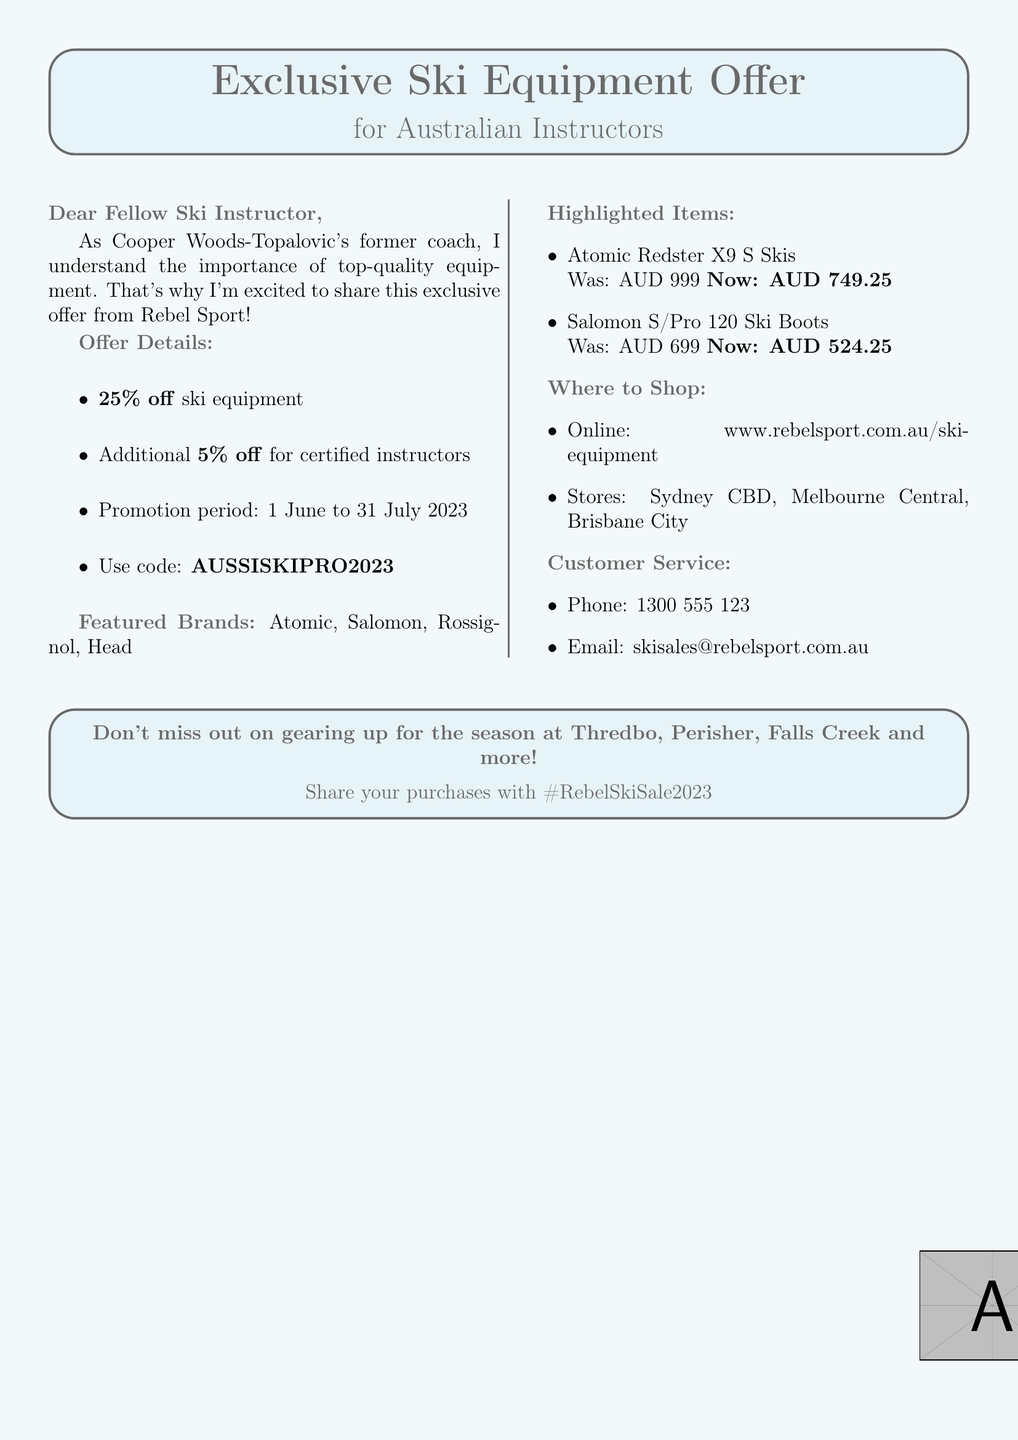what is the discount percentage offered on ski equipment? The document states that there is a discount of 25% on ski equipment.
Answer: 25% what is the exclusive offer for certified ski instructors? The document mentions an additional 5% off for certified ski instructors.
Answer: 5% what is the promotion period for the offer? The document specifies that the promotion period is from 1 June to 31 July 2023.
Answer: 1 June to 31 July 2023 which ski brand is featured in the promotion? The document lists Atomic, Salomon, Rossignol, and Head as featured brands.
Answer: Atomic, Salomon, Rossignol, Head what is the discounted price of the Atomic Redster X9 S Skis? The document states the discounted price of the Atomic Redster X9 S Skis is AUD 749.25.
Answer: AUD 749.25 what is the redemption code for the special offer? The redemption code provided in the document is AUSSISKIPRO2023.
Answer: AUSSISKIPRO2023 how many store locations are mentioned in the document? The document lists three store locations: Sydney CBD, Melbourne Central, and Brisbane City.
Answer: 3 where can customers shop online? The document indicates that customers can shop online at www.rebelsport.com.au/ski-equipment.
Answer: www.rebelsport.com.au/ski-equipment what is the customer service email contact? The contact email for customer service mentioned in the document is skisales@rebelsport.com.au.
Answer: skisales@rebelsport.com.au 